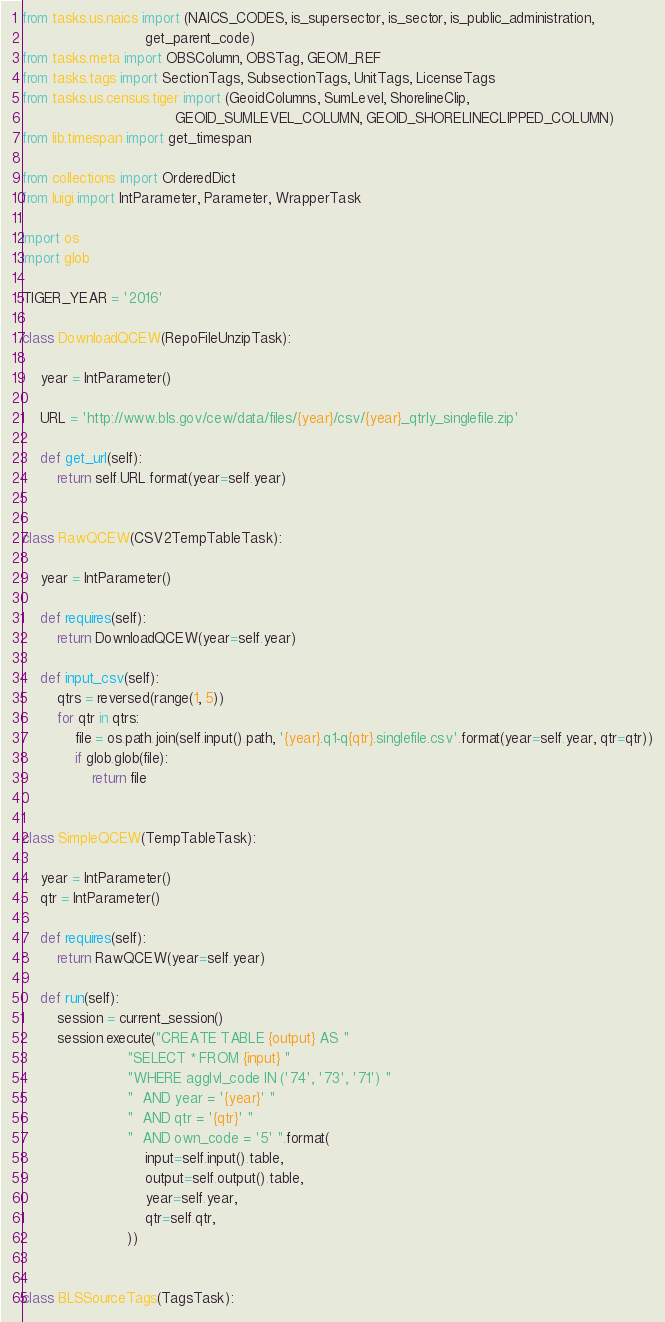<code> <loc_0><loc_0><loc_500><loc_500><_Python_>from tasks.us.naics import (NAICS_CODES, is_supersector, is_sector, is_public_administration,
                            get_parent_code)
from tasks.meta import OBSColumn, OBSTag, GEOM_REF
from tasks.tags import SectionTags, SubsectionTags, UnitTags, LicenseTags
from tasks.us.census.tiger import (GeoidColumns, SumLevel, ShorelineClip,
                                   GEOID_SUMLEVEL_COLUMN, GEOID_SHORELINECLIPPED_COLUMN)
from lib.timespan import get_timespan

from collections import OrderedDict
from luigi import IntParameter, Parameter, WrapperTask

import os
import glob

TIGER_YEAR = '2016'

class DownloadQCEW(RepoFileUnzipTask):

    year = IntParameter()

    URL = 'http://www.bls.gov/cew/data/files/{year}/csv/{year}_qtrly_singlefile.zip'

    def get_url(self):
        return self.URL.format(year=self.year)


class RawQCEW(CSV2TempTableTask):

    year = IntParameter()

    def requires(self):
        return DownloadQCEW(year=self.year)

    def input_csv(self):
        qtrs = reversed(range(1, 5))
        for qtr in qtrs:
            file = os.path.join(self.input().path, '{year}.q1-q{qtr}.singlefile.csv'.format(year=self.year, qtr=qtr))
            if glob.glob(file):
                return file


class SimpleQCEW(TempTableTask):

    year = IntParameter()
    qtr = IntParameter()

    def requires(self):
        return RawQCEW(year=self.year)

    def run(self):
        session = current_session()
        session.execute("CREATE TABLE {output} AS "
                        "SELECT * FROM {input} "
                        "WHERE agglvl_code IN ('74', '73', '71') "
                        "  AND year = '{year}' "
                        "  AND qtr = '{qtr}' "
                        "  AND own_code = '5' ".format(
                            input=self.input().table,
                            output=self.output().table,
                            year=self.year,
                            qtr=self.qtr,
                        ))


class BLSSourceTags(TagsTask):</code> 